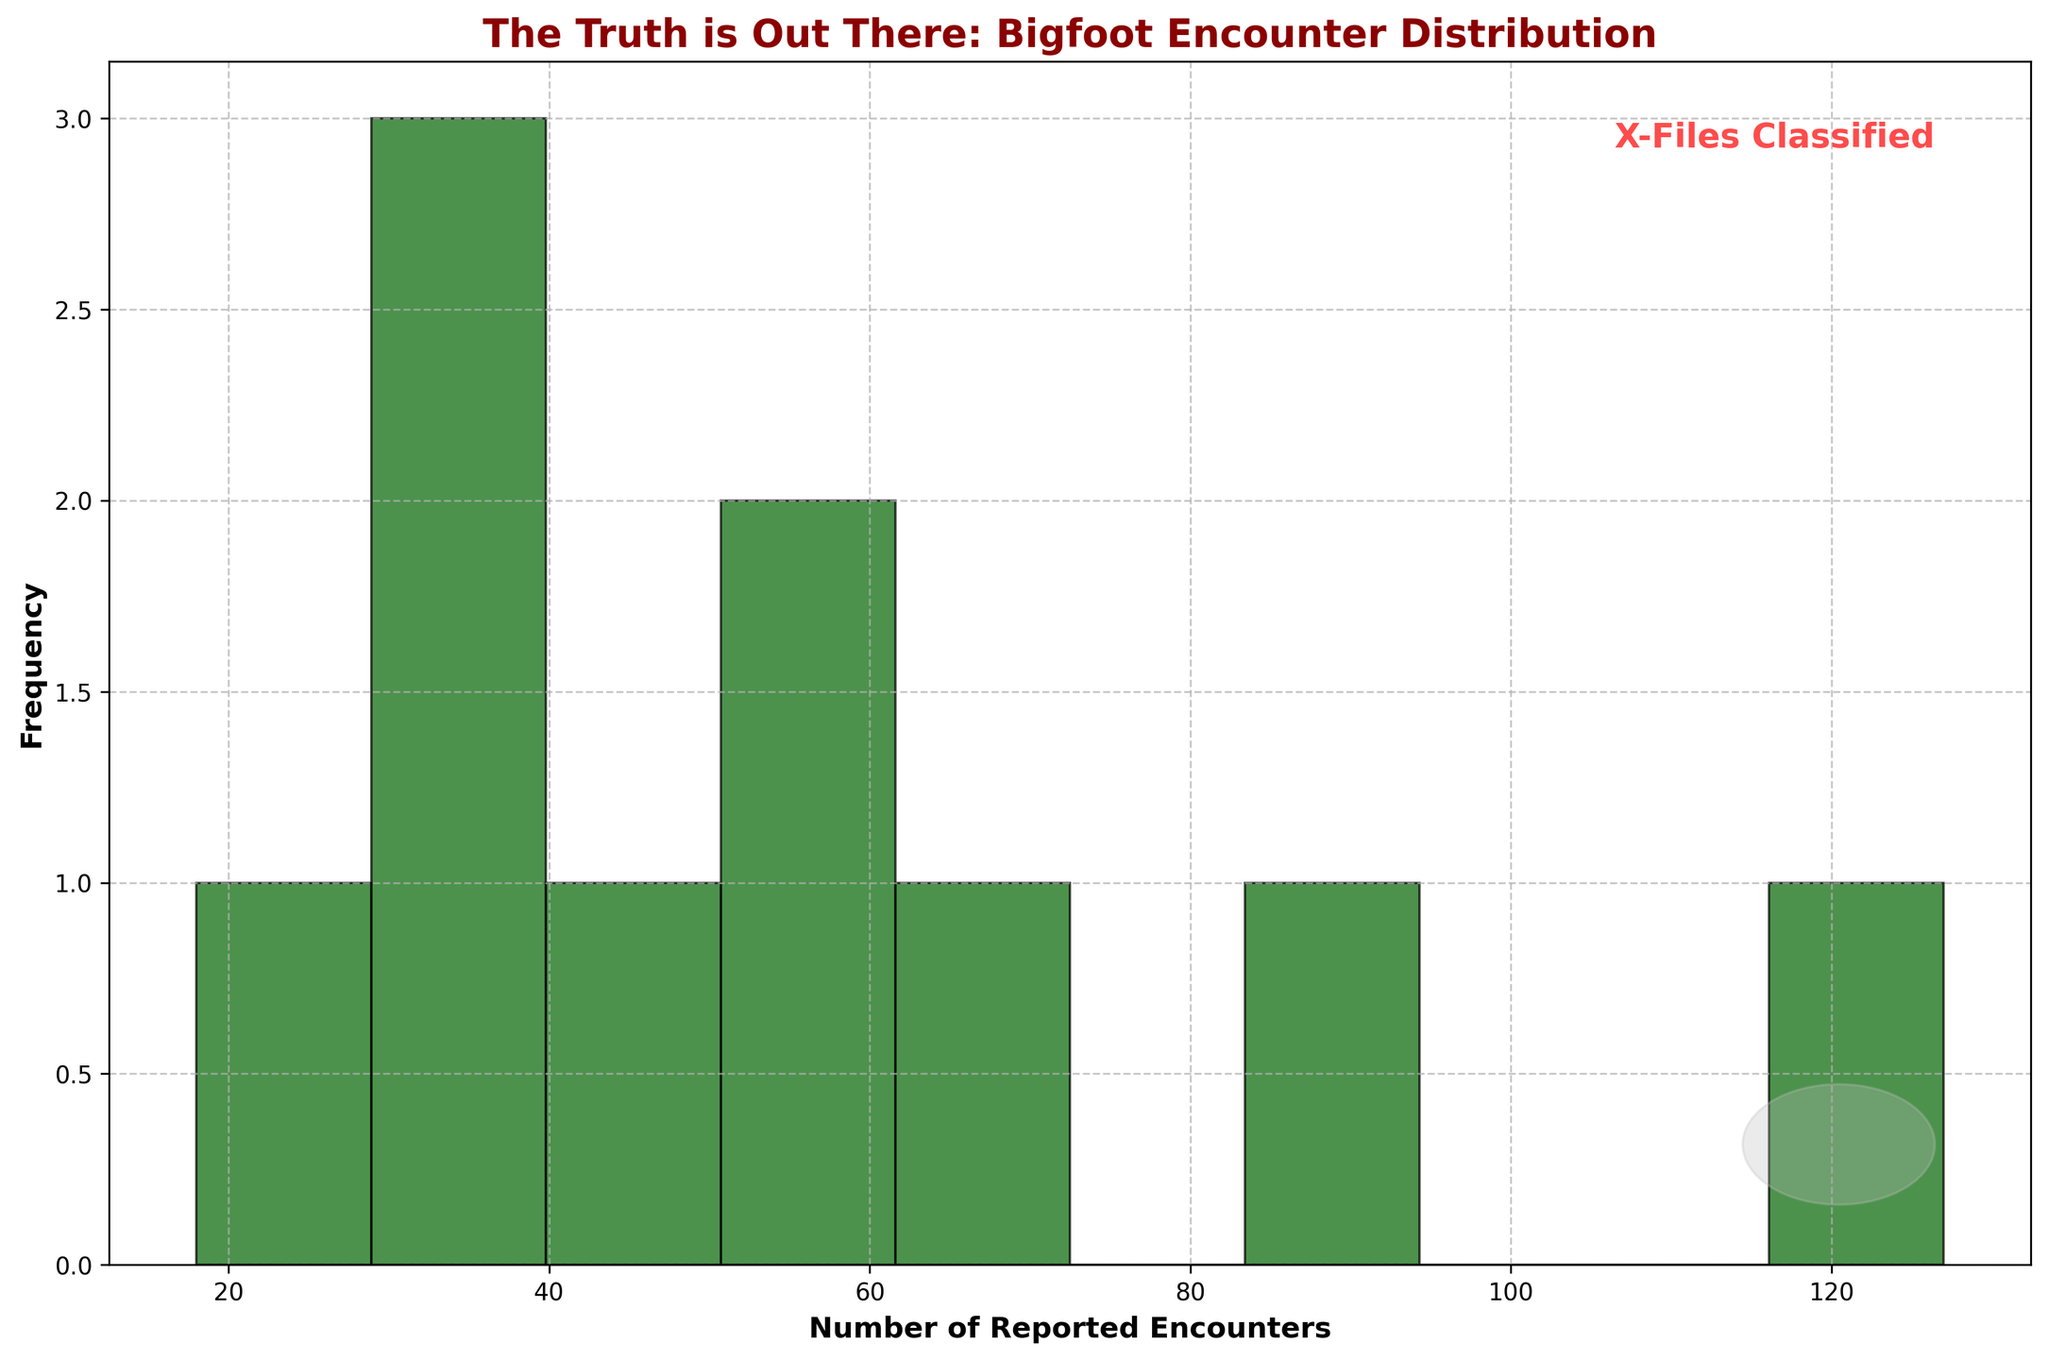What's the title of the figure? The title is located at the top of the chart, showing the summary of what the chart represents. The title is "The Truth is Out There: Bigfoot Encounter Distribution."
Answer: The Truth is Out There: Bigfoot Encounter Distribution How is the frequency represented in this histogram? The frequency is represented by the height of the bars, with the y-axis labeled "Frequency" displaying the count of terrain types within different ranges of reported encounters.
Answer: Height of bars What does the x-axis represent? The x-axis labels the different ranges of the number of reported encounters, indicating the distribution across various terrains. The label reads "Number of Reported Encounters."
Answer: Number of Reported Encounters Which terrain type has the highest number of reported Bigfoot encounters? The terrain type with the peak number of bar counts represents the highest reported encounters. Dense Forest, which is the tallest bar in the histogram, has the highest number of reported encounters.
Answer: Dense Forest What is the frequency of terrains with reported encounters in the range of 20-40? To determine this, observe how many bars fall into the 20-40 range on the x-axis. There are three bars indicating terrains with frequencies in that range: Swamps, Boreal Forest, and Rocky Foothills.
Answer: 3 What's the difference in reported encounters between Dense Forest and Coastal Forests? Dense Forest has 127 encounters, and Coastal Forests have 33. Calculating the difference involves subtracting the smaller number from the larger: 127 - 33 = 94 encounters.
Answer: 94 Which terrain type falls within the mid-range of reported encounters (between 50 and 80)? Identify bars that fit into this range on the histogram. Temperate Rainforest and Redwood Groves fall within the 50 to 80 range for reported encounters.
Answer: Temperate Rainforest and Redwood Groves How many terrain types have more than 50 reported encounters? Count the number of bars whose heights correspond to more than 50 encounters. Dense Forest, Mountain Ranges, River Valleys, Temperate Rainforest, and Redwood Groves surpass this threshold.
Answer: 5 What range of reported encounters is least frequent on this histogram? Look for the shortest bar or bars representing the least frequent encounter ranges. The range 10-20 has the least frequency, which includes Alpine Meadows.
Answer: 10-20 What special annotation or symbol can be found on the chart apart from the bars and grid? The histogram has a text annotation "X-Files Classified" and a subtle UFO shape located in the lower right section of the plot, indicated by a grey circular mark.
Answer: Text annotation and UFO shape 